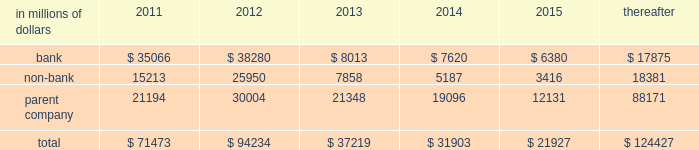Cgmhi has committed long-term financing facilities with unaffiliated banks .
At december 31 , 2010 , cgmhi had drawn down the full $ 900 million available under these facilities , of which $ 150 million is guaranteed by citigroup .
Generally , a bank can terminate these facilities by giving cgmhi one-year prior notice .
The company issues both fixed and variable rate debt in a range of currencies .
It uses derivative contracts , primarily interest rate swaps , to effectively convert a portion of its fixed rate debt to variable rate debt and variable rate debt to fixed rate debt .
The maturity structure of the derivatives generally corresponds to the maturity structure of the debt being hedged .
In addition , the company uses other derivative contracts to manage the foreign exchange impact of certain debt issuances .
At december 31 , 2010 , the company 2019s overall weighted average interest rate for long-term debt was 3.53% ( 3.53 % ) on a contractual basis and 2.78% ( 2.78 % ) including the effects of derivative contracts .
Aggregate annual maturities of long-term debt obligations ( based on final maturity dates ) including trust preferred securities are as follows : long-term debt at december 31 , 2010 and december 31 , 2009 includes $ 18131 million and $ 19345 million , respectively , of junior subordinated debt .
The company formed statutory business trusts under the laws of the state of delaware .
The trusts exist for the exclusive purposes of ( i ) issuing trust securities representing undivided beneficial interests in the assets of the trust ; ( ii ) investing the gross proceeds of the trust securities in junior subordinated deferrable interest debentures ( subordinated debentures ) of its parent ; and ( iii ) engaging in only those activities necessary or incidental thereto .
Upon approval from the federal reserve , citigroup has the right to redeem these securities .
Citigroup has contractually agreed not to redeem or purchase ( i ) the 6.50% ( 6.50 % ) enhanced trust preferred securities of citigroup capital xv before september 15 , 2056 , ( ii ) the 6.45% ( 6.45 % ) enhanced trust preferred securities of citigroup capital xvi before december 31 , 2046 , ( iii ) the 6.35% ( 6.35 % ) enhanced trust preferred securities of citigroup capital xvii before march 15 , 2057 , ( iv ) the 6.829% ( 6.829 % ) fixed rate/floating rate enhanced trust preferred securities of citigroup capital xviii before june 28 , 2047 , ( v ) the 7.250% ( 7.250 % ) enhanced trust preferred securities of citigroup capital xix before august 15 , 2047 , ( vi ) the 7.875% ( 7.875 % ) enhanced trust preferred securities of citigroup capital xx before december 15 , 2067 , and ( vii ) the 8.300% ( 8.300 % ) fixed rate/floating rate enhanced trust preferred securities of citigroup capital xxi before december 21 , 2067 , unless certain conditions , described in exhibit 4.03 to citigroup 2019s current report on form 8-k filed on september 18 , 2006 , in exhibit 4.02 to citigroup 2019s current report on form 8-k filed on november 28 , 2006 , in exhibit 4.02 to citigroup 2019s current report on form 8-k filed on march 8 , 2007 , in exhibit 4.02 to citigroup 2019s current report on form 8-k filed on july 2 , 2007 , in exhibit 4.02 to citigroup 2019s current report on form 8-k filed on august 17 , 2007 , in exhibit 4.2 to citigroup 2019s current report on form 8-k filed on november 27 , 2007 , and in exhibit 4.2 to citigroup 2019s current report on form 8-k filed on december 21 , 2007 , respectively , are met .
These agreements are for the benefit of the holders of citigroup 2019s 6.00% ( 6.00 % ) junior subordinated deferrable interest debentures due 2034 .
Citigroup owns all of the voting securities of these subsidiary trusts .
These subsidiary trusts have no assets , operations , revenues or cash flows other than those related to the issuance , administration , and repayment of the subsidiary trusts and the subsidiary trusts 2019 common securities .
These subsidiary trusts 2019 obligations are fully and unconditionally guaranteed by citigroup. .

What was the percentage increase in the bank subsidiary trusts 2019 obligations from 2011 to 2012? 
Computations: ((38280 - 35066) - 35066)
Answer: -31852.0. 